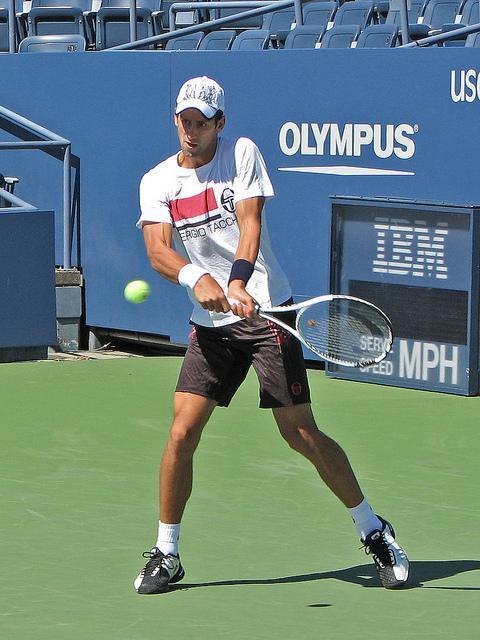How many ties are there?
Give a very brief answer. 0. 